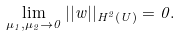Convert formula to latex. <formula><loc_0><loc_0><loc_500><loc_500>\lim _ { \mu _ { 1 } , \mu _ { 2 } \rightarrow 0 } | | w | | _ { H ^ { 2 } ( U ) } = 0 .</formula> 